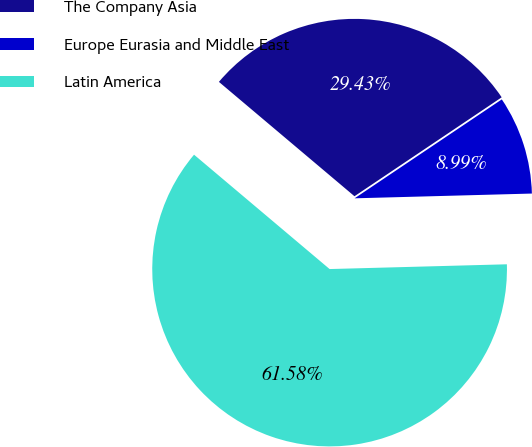Convert chart to OTSL. <chart><loc_0><loc_0><loc_500><loc_500><pie_chart><fcel>The Company Asia<fcel>Europe Eurasia and Middle East<fcel>Latin America<nl><fcel>29.43%<fcel>8.99%<fcel>61.58%<nl></chart> 